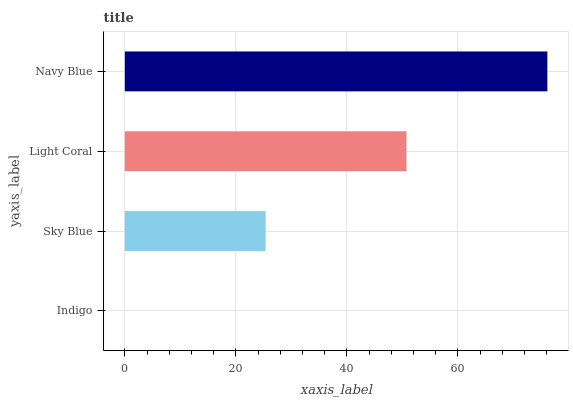Is Indigo the minimum?
Answer yes or no. Yes. Is Navy Blue the maximum?
Answer yes or no. Yes. Is Sky Blue the minimum?
Answer yes or no. No. Is Sky Blue the maximum?
Answer yes or no. No. Is Sky Blue greater than Indigo?
Answer yes or no. Yes. Is Indigo less than Sky Blue?
Answer yes or no. Yes. Is Indigo greater than Sky Blue?
Answer yes or no. No. Is Sky Blue less than Indigo?
Answer yes or no. No. Is Light Coral the high median?
Answer yes or no. Yes. Is Sky Blue the low median?
Answer yes or no. Yes. Is Indigo the high median?
Answer yes or no. No. Is Indigo the low median?
Answer yes or no. No. 